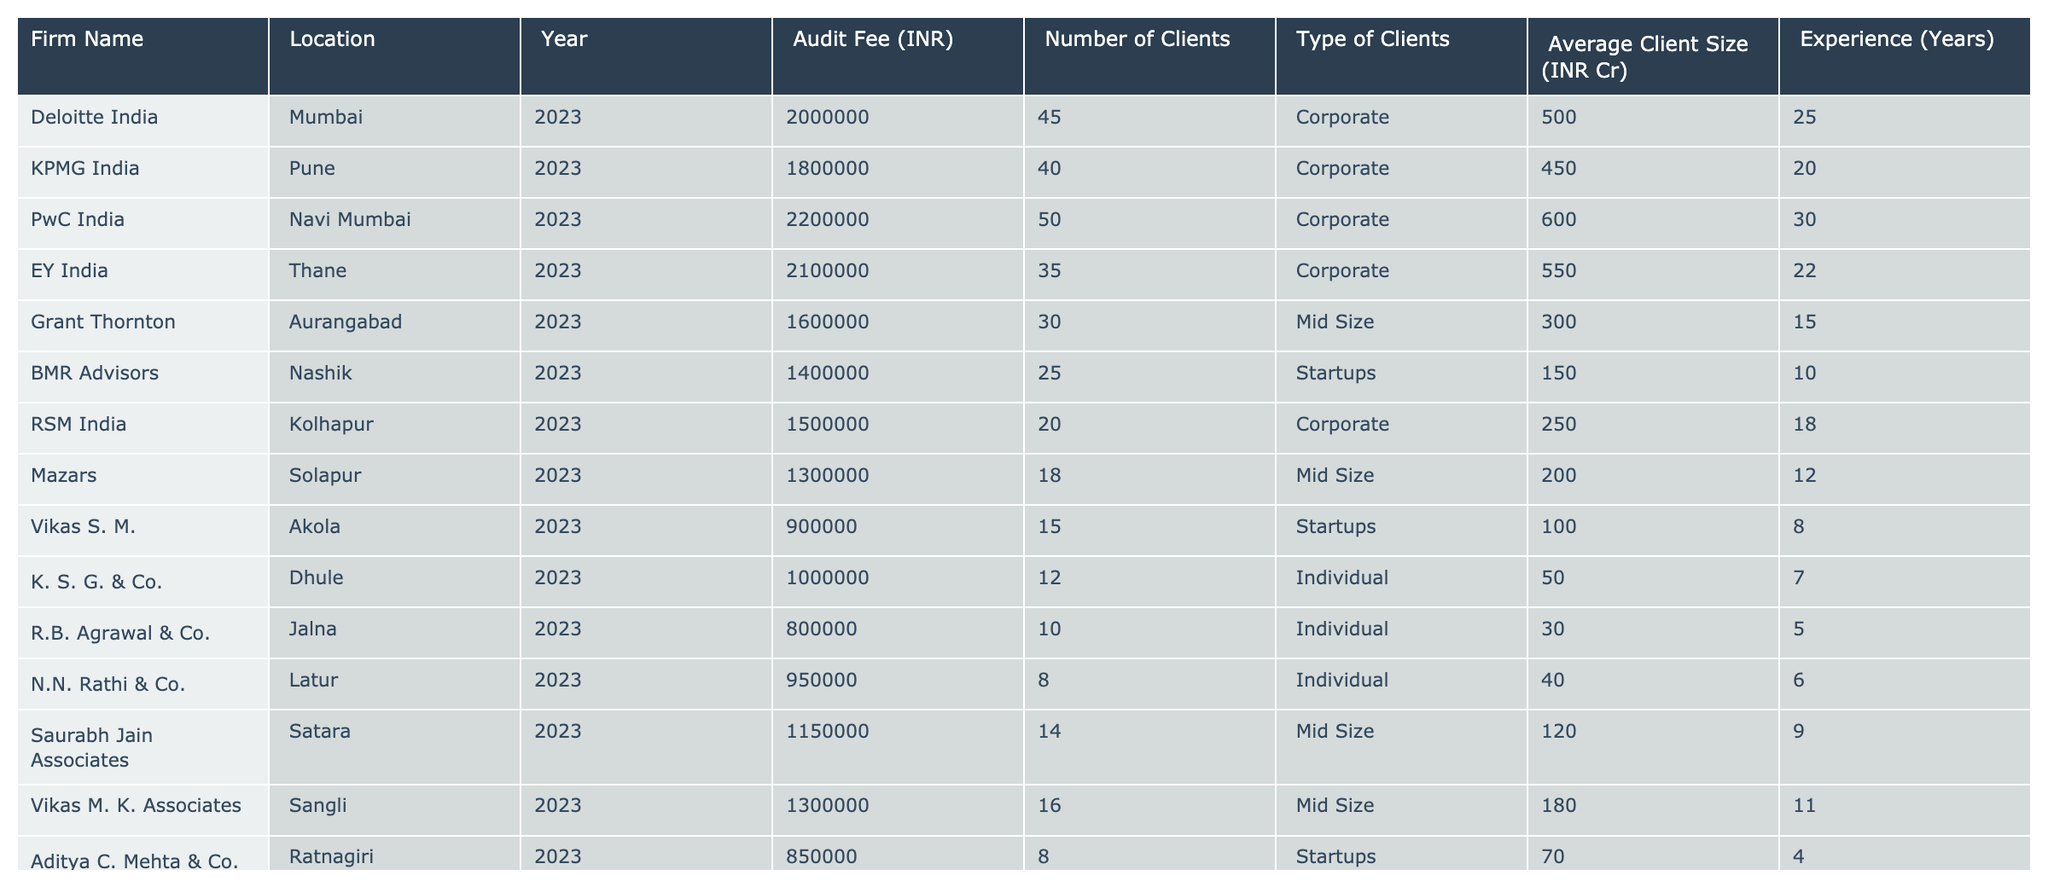What is the audit fee charged by PwC India? The table lists the audit fee for PwC India as 2,200,000 INR for the year 2023.
Answer: 2,200,000 INR Which firm has the highest audit fee? By reviewing the fees in the table, PwC India charges the highest at 2,200,000 INR for 2023.
Answer: PwC India How many clients does KPMG India serve? The table shows that KPMG India has 40 clients for the year 2023.
Answer: 40 What is the average audit fee of firms that serve Individual clients? The audit fees for the firms serving Individual clients are 1,000,000 INR, 800,000 INR, and 950,000 INR. The total is 2,750,000 INR and there are 3 firms, so the average is 2,750,000 / 3 = 916,667 INR.
Answer: 916,667 INR Which firm has the least experience among the firms listed? Looking at the 'Experience' column, Vikas S. M. from Akola has the least experience with 8 years.
Answer: Vikas S. M What is the total audit fee charged by all firms in Maharashtra? Summing all the audit fees: 2,000,000 + 1,800,000 + 2,200,000 + 2,100,000 + 1,600,000 + 1,400,000 + 1,500,000 + 1,300,000 + 900,000 + 1,000,000 + 800,000 + 950,000 + 1,150,000 + 1,300,000 + 850,000 + 1,200,000 = 19,000,000 INR.
Answer: 19,000,000 INR Is there any firm that charges less than 1,000,000 INR? From the table, Vikas S. M. charges 900,000 INR, which is less than 1,000,000.
Answer: Yes How many firms are serving Mid Size clients? The firms serving Mid Size clients are Grant Thornton, Mazars, Saurabh Jain Associates, and Vikas M. K. Associates. That makes a total of 4 firms.
Answer: 4 What is the average client size (INR Cr) for firms serving Corporate clients? The average client sizes are 500, 450, 600, and 250 for Deloitte, KPMG, PwC, and RSM respectively. The total is 1,900, divided by 4 gives an average client size of 475 INR Cr.
Answer: 475 INR Cr Which firm's fee is closest to the average audit fee of all firms? The average audit fee is 1,187,500 INR. The closest fee is that of RSM India at 1,500,000 INR.
Answer: RSM India What percentage of the total clients is served by the firm with the highest audit fee? The highest fee is charged by PwC India with 50 clients. The total clients across all firms are 45 + 40 + 50 + 35 + 30 + 25 + 20 + 18 + 15 + 12 + 10 + 8 + 14 + 16 + 8 + 10 =  414. PwC's share percentage is (50 / 414) * 100 = 12.1%.
Answer: 12.1% 